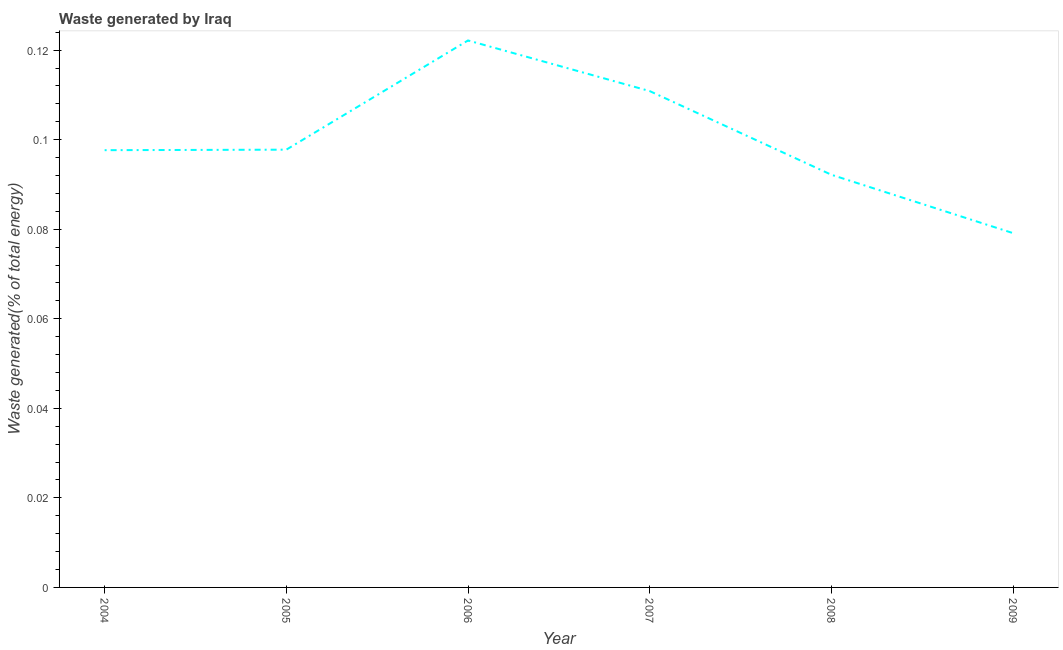What is the amount of waste generated in 2007?
Offer a terse response. 0.11. Across all years, what is the maximum amount of waste generated?
Ensure brevity in your answer.  0.12. Across all years, what is the minimum amount of waste generated?
Keep it short and to the point. 0.08. In which year was the amount of waste generated maximum?
Keep it short and to the point. 2006. In which year was the amount of waste generated minimum?
Provide a short and direct response. 2009. What is the sum of the amount of waste generated?
Offer a very short reply. 0.6. What is the difference between the amount of waste generated in 2004 and 2005?
Give a very brief answer. -0. What is the average amount of waste generated per year?
Provide a short and direct response. 0.1. What is the median amount of waste generated?
Provide a short and direct response. 0.1. In how many years, is the amount of waste generated greater than 0.076 %?
Ensure brevity in your answer.  6. Do a majority of the years between 2009 and 2004 (inclusive) have amount of waste generated greater than 0.064 %?
Provide a short and direct response. Yes. What is the ratio of the amount of waste generated in 2006 to that in 2008?
Ensure brevity in your answer.  1.33. What is the difference between the highest and the second highest amount of waste generated?
Make the answer very short. 0.01. Is the sum of the amount of waste generated in 2005 and 2009 greater than the maximum amount of waste generated across all years?
Offer a very short reply. Yes. What is the difference between the highest and the lowest amount of waste generated?
Provide a short and direct response. 0.04. Does the amount of waste generated monotonically increase over the years?
Make the answer very short. No. How many years are there in the graph?
Your answer should be compact. 6. What is the difference between two consecutive major ticks on the Y-axis?
Your response must be concise. 0.02. Does the graph contain any zero values?
Ensure brevity in your answer.  No. Does the graph contain grids?
Offer a very short reply. No. What is the title of the graph?
Your answer should be compact. Waste generated by Iraq. What is the label or title of the X-axis?
Your answer should be very brief. Year. What is the label or title of the Y-axis?
Offer a very short reply. Waste generated(% of total energy). What is the Waste generated(% of total energy) in 2004?
Offer a terse response. 0.1. What is the Waste generated(% of total energy) in 2005?
Make the answer very short. 0.1. What is the Waste generated(% of total energy) in 2006?
Your response must be concise. 0.12. What is the Waste generated(% of total energy) in 2007?
Offer a very short reply. 0.11. What is the Waste generated(% of total energy) in 2008?
Give a very brief answer. 0.09. What is the Waste generated(% of total energy) in 2009?
Make the answer very short. 0.08. What is the difference between the Waste generated(% of total energy) in 2004 and 2005?
Offer a very short reply. -0. What is the difference between the Waste generated(% of total energy) in 2004 and 2006?
Your answer should be very brief. -0.02. What is the difference between the Waste generated(% of total energy) in 2004 and 2007?
Your answer should be very brief. -0.01. What is the difference between the Waste generated(% of total energy) in 2004 and 2008?
Offer a very short reply. 0.01. What is the difference between the Waste generated(% of total energy) in 2004 and 2009?
Your answer should be compact. 0.02. What is the difference between the Waste generated(% of total energy) in 2005 and 2006?
Your answer should be compact. -0.02. What is the difference between the Waste generated(% of total energy) in 2005 and 2007?
Offer a very short reply. -0.01. What is the difference between the Waste generated(% of total energy) in 2005 and 2008?
Make the answer very short. 0.01. What is the difference between the Waste generated(% of total energy) in 2005 and 2009?
Offer a very short reply. 0.02. What is the difference between the Waste generated(% of total energy) in 2006 and 2007?
Your response must be concise. 0.01. What is the difference between the Waste generated(% of total energy) in 2006 and 2008?
Offer a terse response. 0.03. What is the difference between the Waste generated(% of total energy) in 2006 and 2009?
Make the answer very short. 0.04. What is the difference between the Waste generated(% of total energy) in 2007 and 2008?
Your answer should be compact. 0.02. What is the difference between the Waste generated(% of total energy) in 2007 and 2009?
Give a very brief answer. 0.03. What is the difference between the Waste generated(% of total energy) in 2008 and 2009?
Your answer should be very brief. 0.01. What is the ratio of the Waste generated(% of total energy) in 2004 to that in 2006?
Your answer should be very brief. 0.8. What is the ratio of the Waste generated(% of total energy) in 2004 to that in 2007?
Provide a succinct answer. 0.88. What is the ratio of the Waste generated(% of total energy) in 2004 to that in 2008?
Your answer should be very brief. 1.06. What is the ratio of the Waste generated(% of total energy) in 2004 to that in 2009?
Provide a short and direct response. 1.23. What is the ratio of the Waste generated(% of total energy) in 2005 to that in 2007?
Provide a succinct answer. 0.88. What is the ratio of the Waste generated(% of total energy) in 2005 to that in 2008?
Provide a succinct answer. 1.06. What is the ratio of the Waste generated(% of total energy) in 2005 to that in 2009?
Ensure brevity in your answer.  1.24. What is the ratio of the Waste generated(% of total energy) in 2006 to that in 2007?
Offer a terse response. 1.1. What is the ratio of the Waste generated(% of total energy) in 2006 to that in 2008?
Ensure brevity in your answer.  1.32. What is the ratio of the Waste generated(% of total energy) in 2006 to that in 2009?
Keep it short and to the point. 1.54. What is the ratio of the Waste generated(% of total energy) in 2007 to that in 2008?
Provide a succinct answer. 1.2. What is the ratio of the Waste generated(% of total energy) in 2007 to that in 2009?
Offer a very short reply. 1.4. What is the ratio of the Waste generated(% of total energy) in 2008 to that in 2009?
Ensure brevity in your answer.  1.17. 